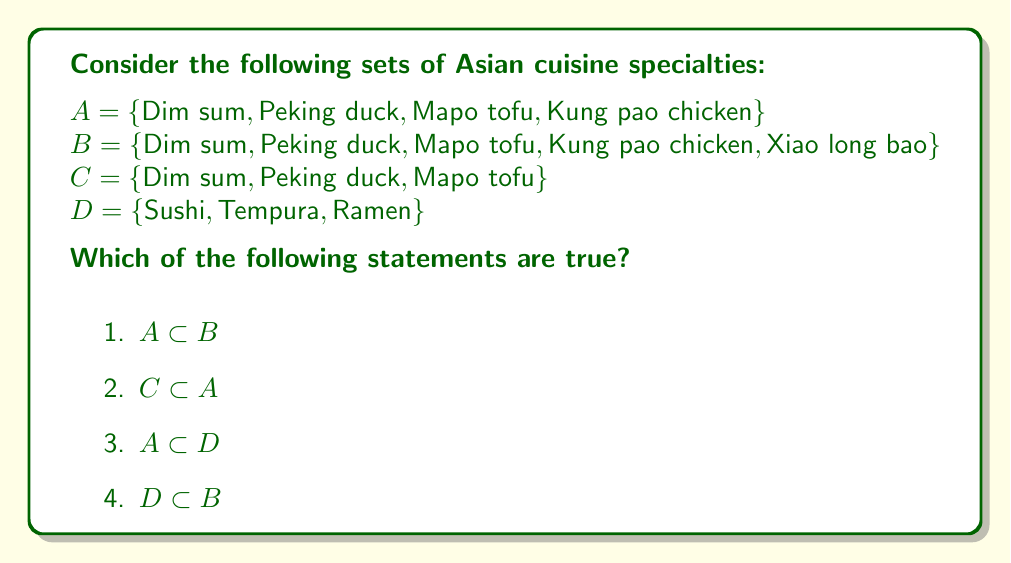Solve this math problem. Let's evaluate each statement:

1) $A \subset B$:
   To determine if $A$ is a proper subset of $B$, we need to check if every element of $A$ is in $B$, and $A \neq B$.
   $\{\text{Dim sum}, \text{Peking duck}, \text{Mapo tofu}, \text{Kung pao chicken}\} \subset \{\text{Dim sum}, \text{Peking duck}, \text{Mapo tofu}, \text{Kung pao chicken}, \text{Xiao long bao}\}$
   We can see that all elements of $A$ are in $B$, and $B$ has an additional element (Xiao long bao). Therefore, $A \subset B$ is true.

2) $C \subset A$:
   $\{\text{Dim sum}, \text{Peking duck}, \text{Mapo tofu}\} \subset \{\text{Dim sum}, \text{Peking duck}, \text{Mapo tofu}, \text{Kung pao chicken}\}$
   All elements of $C$ are in $A$, and $A$ has an additional element (Kung pao chicken). Therefore, $C \subset A$ is true.

3) $A \subset D$:
   $A = \{\text{Dim sum}, \text{Peking duck}, \text{Mapo tofu}, \text{Kung pao chicken}\}$
   $D = \{\text{Sushi}, \text{Tempura}, \text{Ramen}\}$
   None of the elements in $A$ are present in $D$. Therefore, $A \subset D$ is false.

4) $D \subset B$:
   $D = \{\text{Sushi}, \text{Tempura}, \text{Ramen}\}$
   $B = \{\text{Dim sum}, \text{Peking duck}, \text{Mapo tofu}, \text{Kung pao chicken}, \text{Xiao long bao}\}$
   None of the elements in $D$ are present in $B$. Therefore, $D \subset B$ is false.
Answer: The true statements are:
1) $A \subset B$
2) $C \subset A$ 